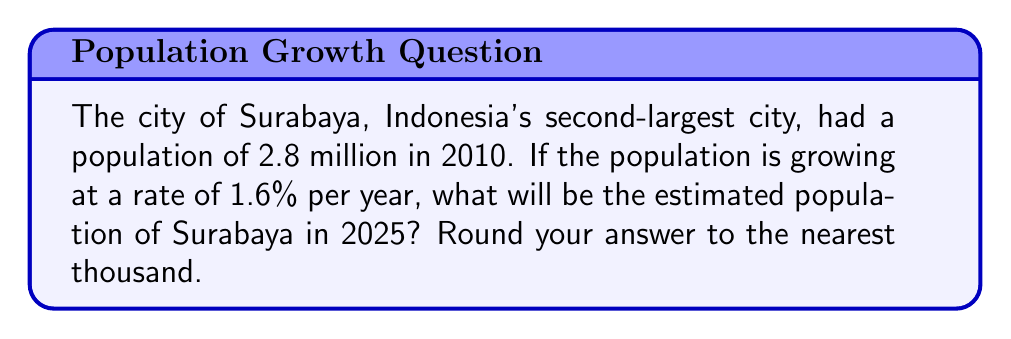Solve this math problem. Let's approach this step-by-step using the exponential growth model:

1) The exponential growth formula is:
   $$P(t) = P_0 \cdot (1 + r)^t$$
   where:
   $P(t)$ is the population after time $t$
   $P_0$ is the initial population
   $r$ is the growth rate (as a decimal)
   $t$ is the time in years

2) Given:
   $P_0 = 2.8$ million (in 2010)
   $r = 1.6\% = 0.016$
   $t = 2025 - 2010 = 15$ years

3) Plugging these values into the formula:
   $$P(15) = 2.8 \cdot (1 + 0.016)^{15}$$

4) Calculate:
   $$P(15) = 2.8 \cdot (1.016)^{15}$$
   $$P(15) = 2.8 \cdot 1.2688$$
   $$P(15) = 3.5526$$ million

5) Rounding to the nearest thousand:
   3,553,000
Answer: 3,553,000 